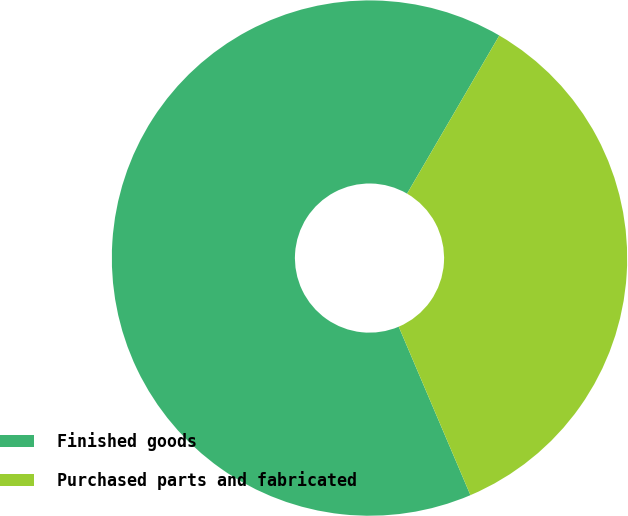Convert chart to OTSL. <chart><loc_0><loc_0><loc_500><loc_500><pie_chart><fcel>Finished goods<fcel>Purchased parts and fabricated<nl><fcel>64.81%<fcel>35.19%<nl></chart> 